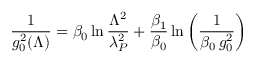Convert formula to latex. <formula><loc_0><loc_0><loc_500><loc_500>{ \frac { 1 } { g _ { 0 } ^ { 2 } ( \Lambda ) } } = \beta _ { 0 } \ln { \frac { \Lambda ^ { 2 } } { \lambda _ { P } ^ { 2 } } } + { \frac { \beta _ { 1 } } { \beta _ { 0 } } } \ln \left ( { \frac { 1 } { \beta _ { 0 } \, g _ { 0 } ^ { 2 } } } \right )</formula> 